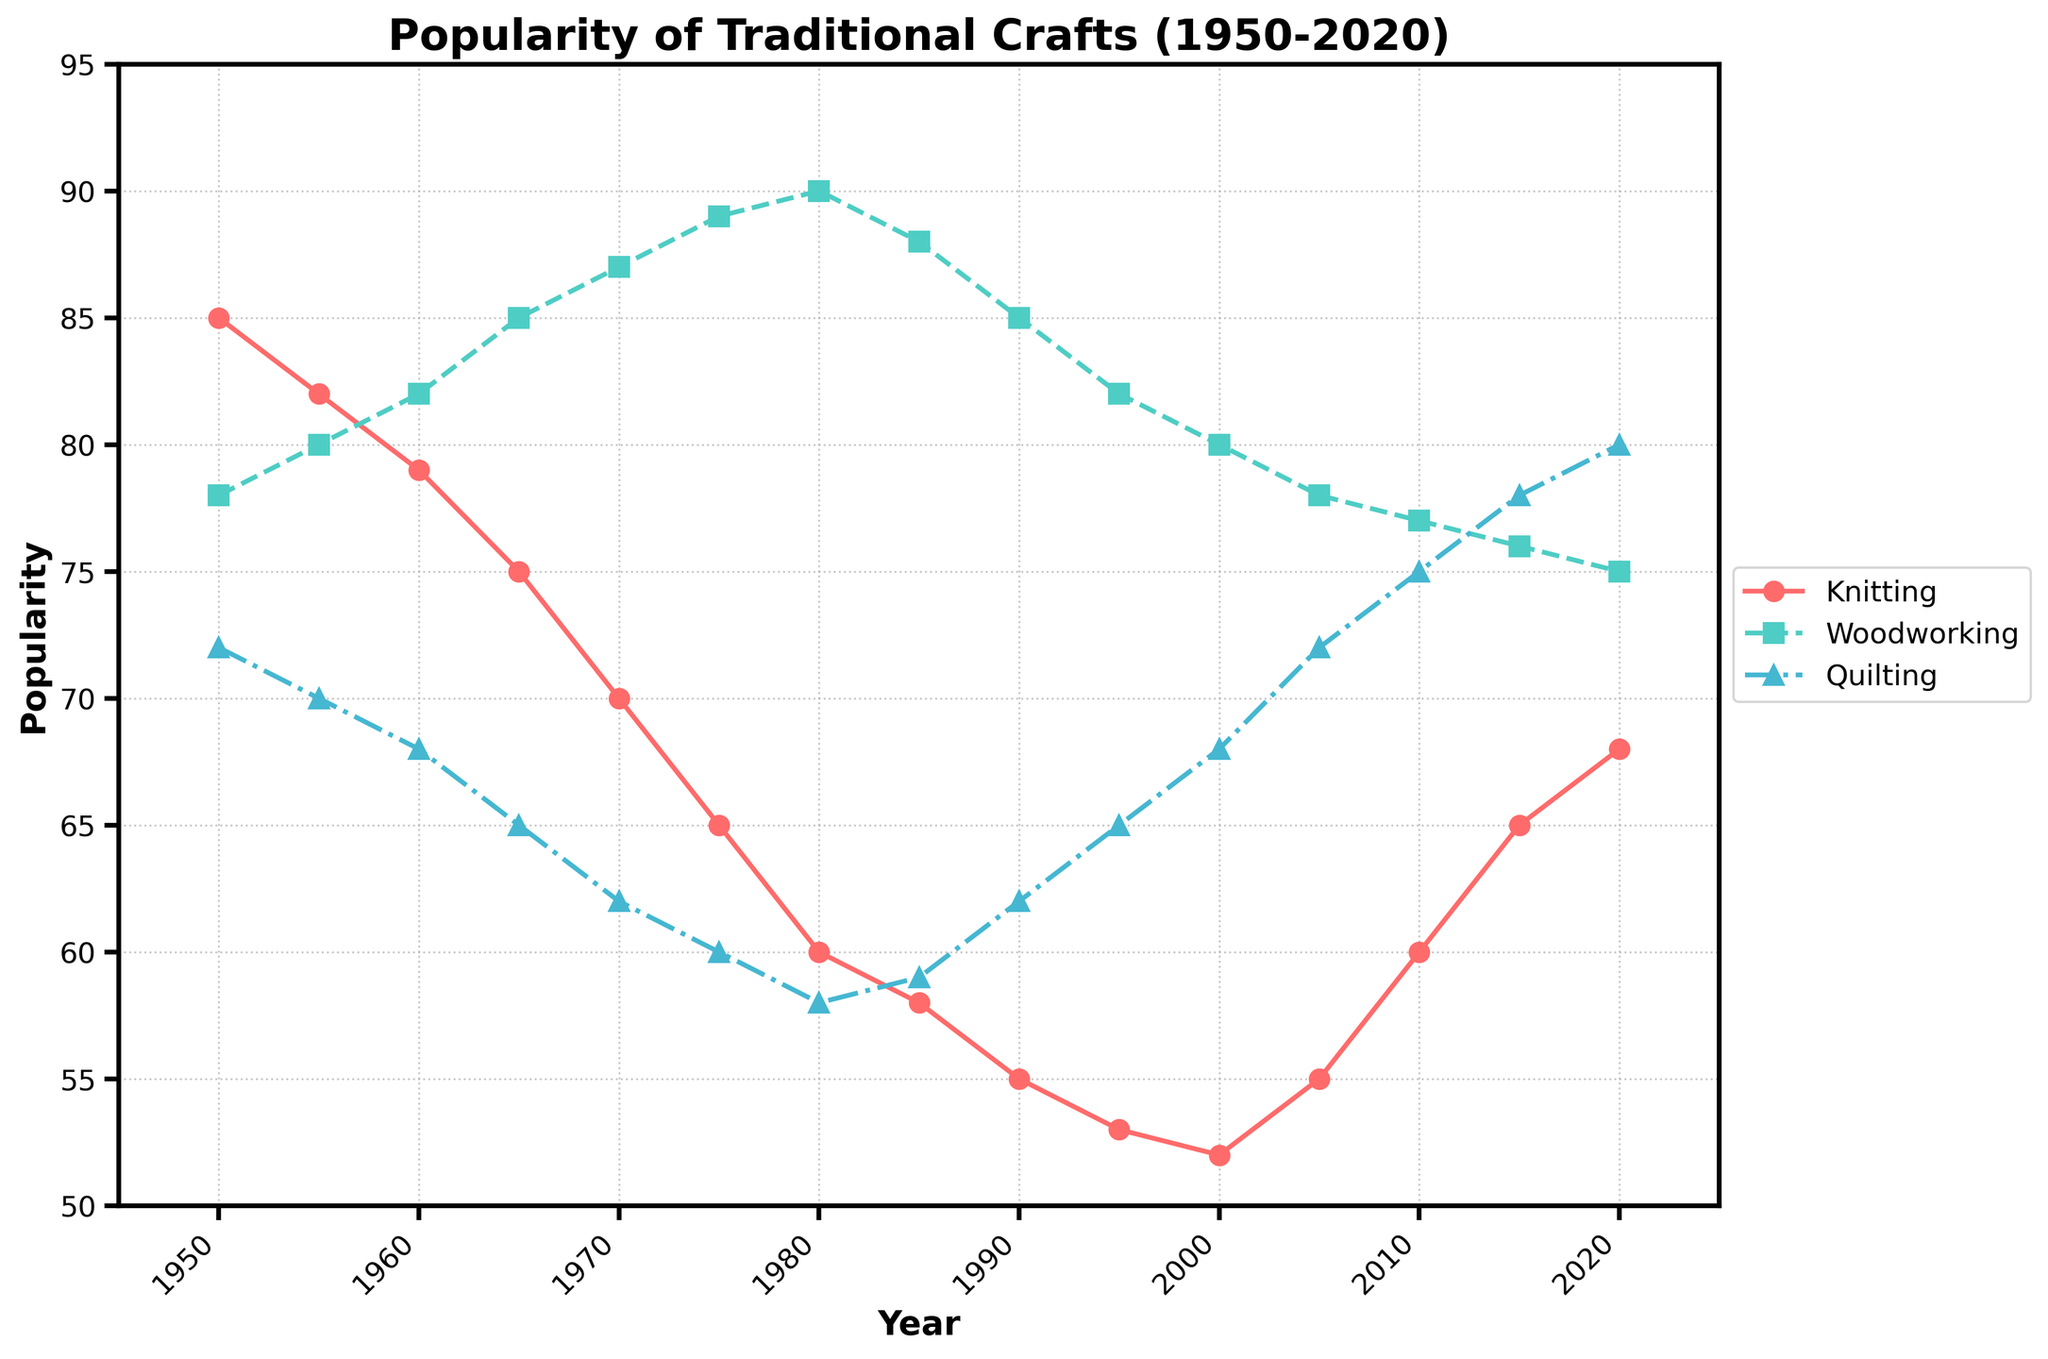How has the popularity of knitting and quilting changed from 1950 to 2020? To determine the change, find the values for knitting and quilting in 1950 and 2020 from the plot. In 1950, knitting was at 85 and in 2020 it was at 68, indicating a decrease of 17 units. For quilting, it was at 72 in 1950 and 80 in 2020, indicating an increase of 8 units.
Answer: Knitting decreased by 17, Quilting increased by 8 Which craft had the steepest decline in popularity between 1950 and 1980? Determine the values at 1950 and 1980 for each craft and calculate the differences. For knitting, (85 - 60) = 25, for woodworking, (78 - 90) = -12 (an increase), and for quilting, (72 - 58) = 14. The steepest decline is for knitting (25 units).
Answer: Knitting In which year did woodworking reach its peak popularity? By examining the plot, locate the year when the line for woodworking (dashed line) reaches its highest point. This occurs in 1980 with a value of 90.
Answer: 1980 Is there a point where all the crafts' popularity values are equal or nearly equal? Observe the plot to find any intersection or closely converging points of all three lines. Around 2015-2020, the lines for knitting, woodworking, and quilting are notably close, at approximately 65-68.
Answer: 2015-2020 Between 2000 and 2020, which craft gained the most in popularity? By comparing the values at 2000 and 2020 for each craft: knitting (52 to 68, gain of 16), woodworking (80 to 75, loss of 5), and quilting (68 to 80, gain of 12). Knitting gained the most (16 units).
Answer: Knitting What is the average popularity of quilting over the 70 years? Determine the sum of the popularity values for quilting from the plot and divide by the number of data points (15). (72 + 70 + 68 + 65 + 62 + 60 + 58 + 59 + 62 + 65 + 68 + 72 + 75 + 78 + 80) = 1014, so the average is 1014/15 = 67.6
Answer: 67.6 Compare the rate of decline for knitting between 1950-1970 and 1970-1990. Which period experienced a faster decline? Calculate the decline: for 1950-1970, (85 - 70) = 15 over 20 years (0.75/year) and for 1970-1990, (70 - 55) = 15 over 20 years (0.75/year). The rates of decline are the same (0.75/year).
Answer: Rates are the same Which craft showed the most fluctuation in popularity? To determine fluctuation, observe the variations and the number of changes in directions in the plot for each craft. Quilting shows multiple up-and-down movements compared to knitting and woodworking.
Answer: Quilting When did knitting's popularity first drop below 60? Look for the year when the solid line representing knitting first dips below 60. This occurs in 1980 when knitting reaches 60.
Answer: 1980 